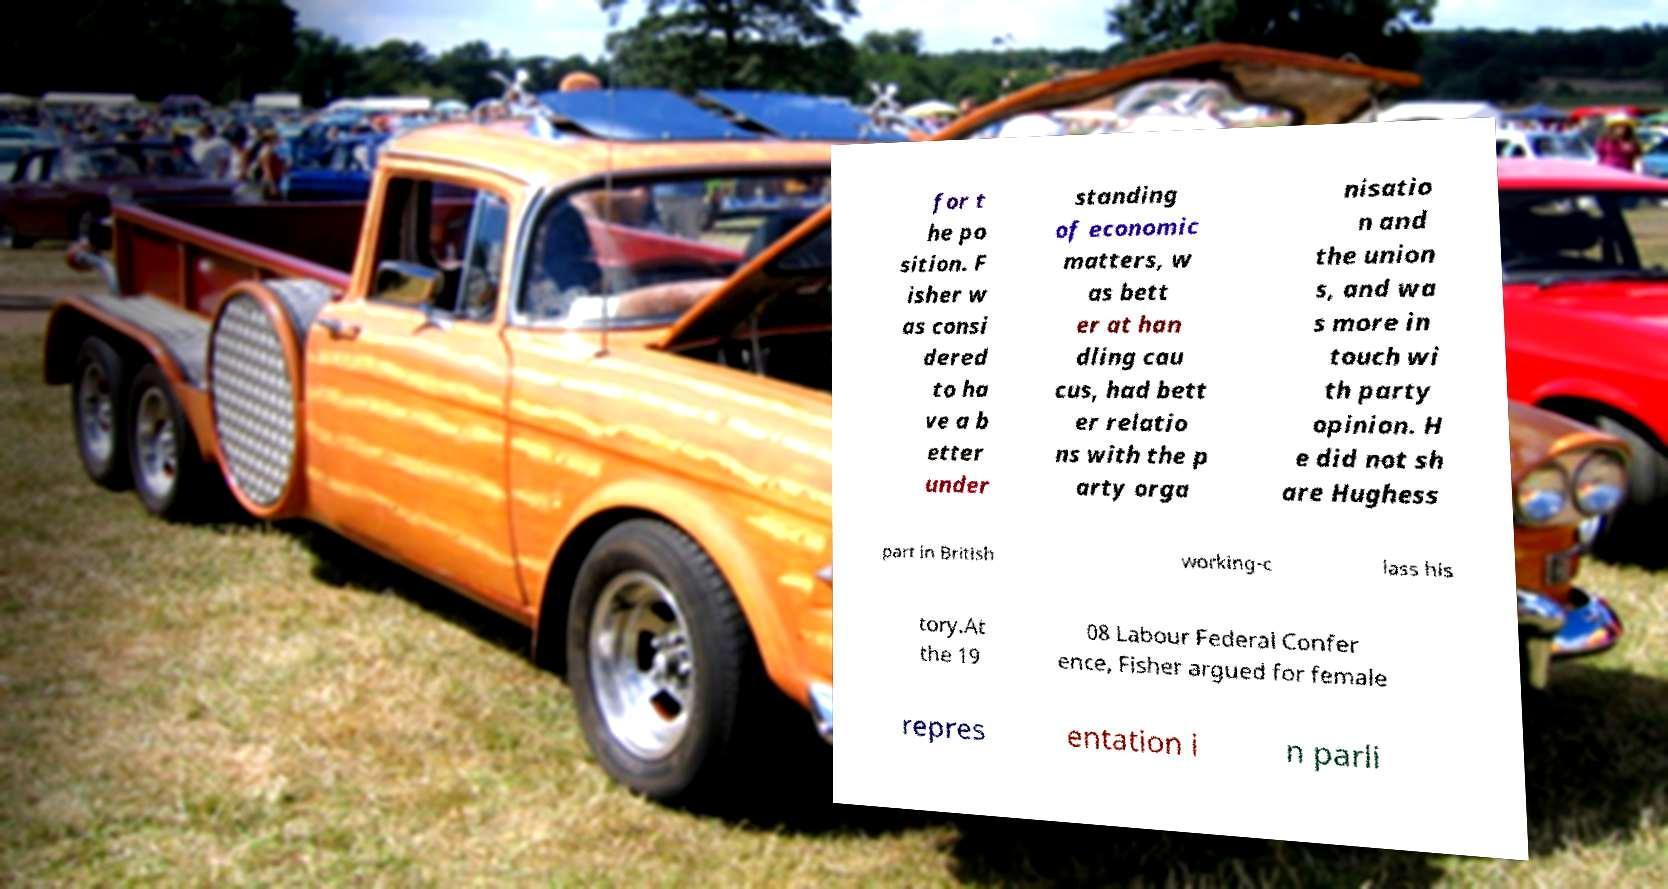Could you assist in decoding the text presented in this image and type it out clearly? for t he po sition. F isher w as consi dered to ha ve a b etter under standing of economic matters, w as bett er at han dling cau cus, had bett er relatio ns with the p arty orga nisatio n and the union s, and wa s more in touch wi th party opinion. H e did not sh are Hughess part in British working-c lass his tory.At the 19 08 Labour Federal Confer ence, Fisher argued for female repres entation i n parli 